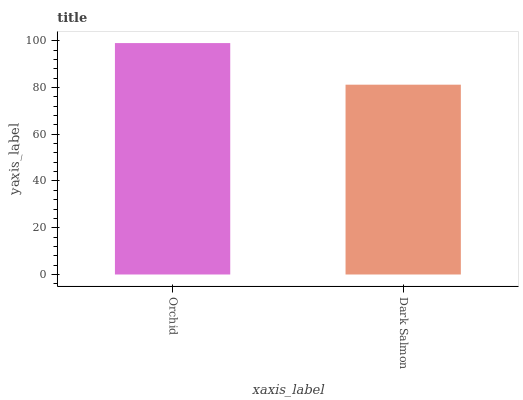Is Dark Salmon the maximum?
Answer yes or no. No. Is Orchid greater than Dark Salmon?
Answer yes or no. Yes. Is Dark Salmon less than Orchid?
Answer yes or no. Yes. Is Dark Salmon greater than Orchid?
Answer yes or no. No. Is Orchid less than Dark Salmon?
Answer yes or no. No. Is Orchid the high median?
Answer yes or no. Yes. Is Dark Salmon the low median?
Answer yes or no. Yes. Is Dark Salmon the high median?
Answer yes or no. No. Is Orchid the low median?
Answer yes or no. No. 